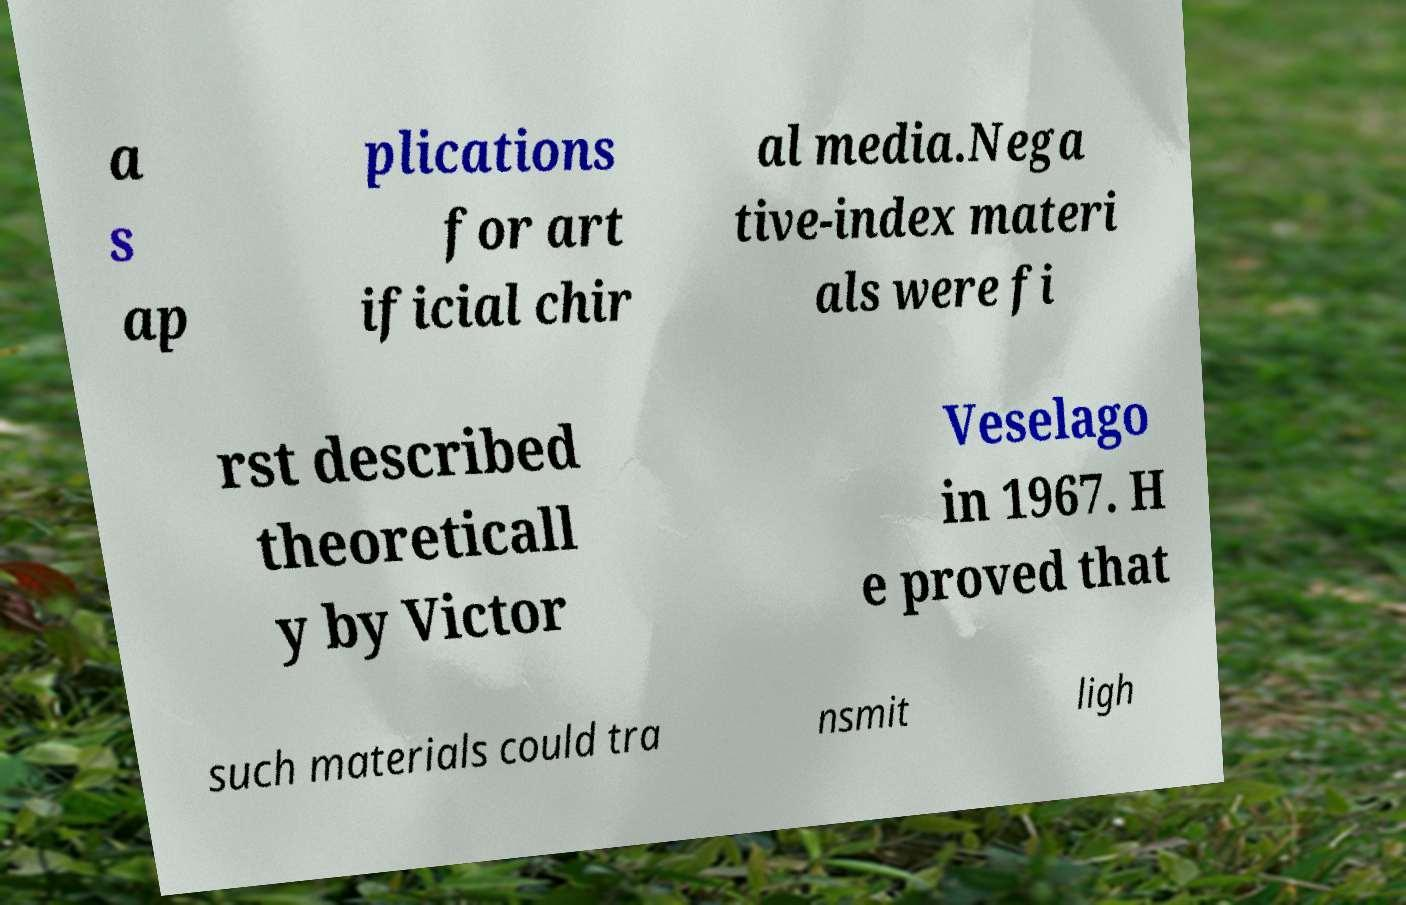Can you read and provide the text displayed in the image?This photo seems to have some interesting text. Can you extract and type it out for me? a s ap plications for art ificial chir al media.Nega tive-index materi als were fi rst described theoreticall y by Victor Veselago in 1967. H e proved that such materials could tra nsmit ligh 